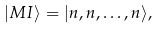<formula> <loc_0><loc_0><loc_500><loc_500>| M I \rangle = | n , n , \dots , n \rangle ,</formula> 